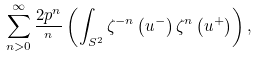Convert formula to latex. <formula><loc_0><loc_0><loc_500><loc_500>\sum _ { n > 0 } ^ { \infty } \frac { 2 p ^ { n } } { ^ { n } } \left ( \int _ { S ^ { 2 } } \zeta ^ { - n } \left ( u ^ { - } \right ) \zeta ^ { n } \left ( u ^ { + } \right ) \right ) ,</formula> 